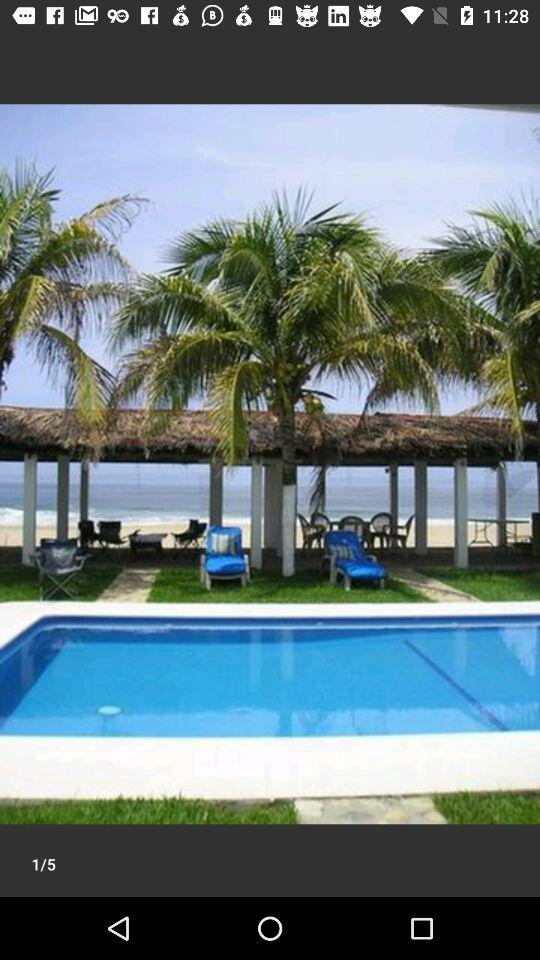At which image am I? You are at image 1. 